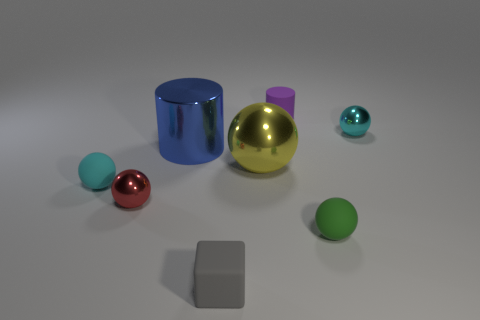How many objects are there in total, and what materials do they resemble? In the image, there are eight objects in total. Starting from the left, there are three matte rubber balls, a shiny metallic cylinder, a glossy metallic sphere, two smaller matte spheres, and what appears to be a matte cube. The materials they resemble include rubber for the matte spheres, metal for the shiny cylinder and large sphere, and perhaps plastic for the cube.  Are there any patterns or themes in the arrangement of these objects? The objects are arranged somewhat asymmetrically with an interesting variation in height and material types. There seems to be a gentle balance in the composition, contrasting colors, and finishes like matte versus glossy, and metallic versus non-metallic, which could suggest a theme of diversity or contrast within unity. 